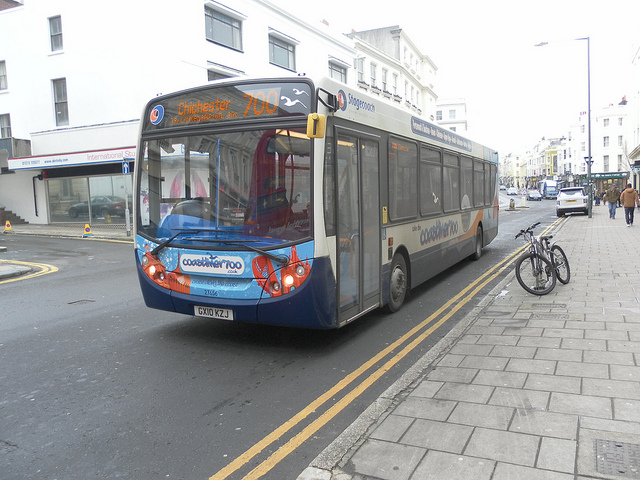Identify the text contained in this image. Chichester 700 coasthner700 